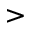Convert formula to latex. <formula><loc_0><loc_0><loc_500><loc_500>></formula> 